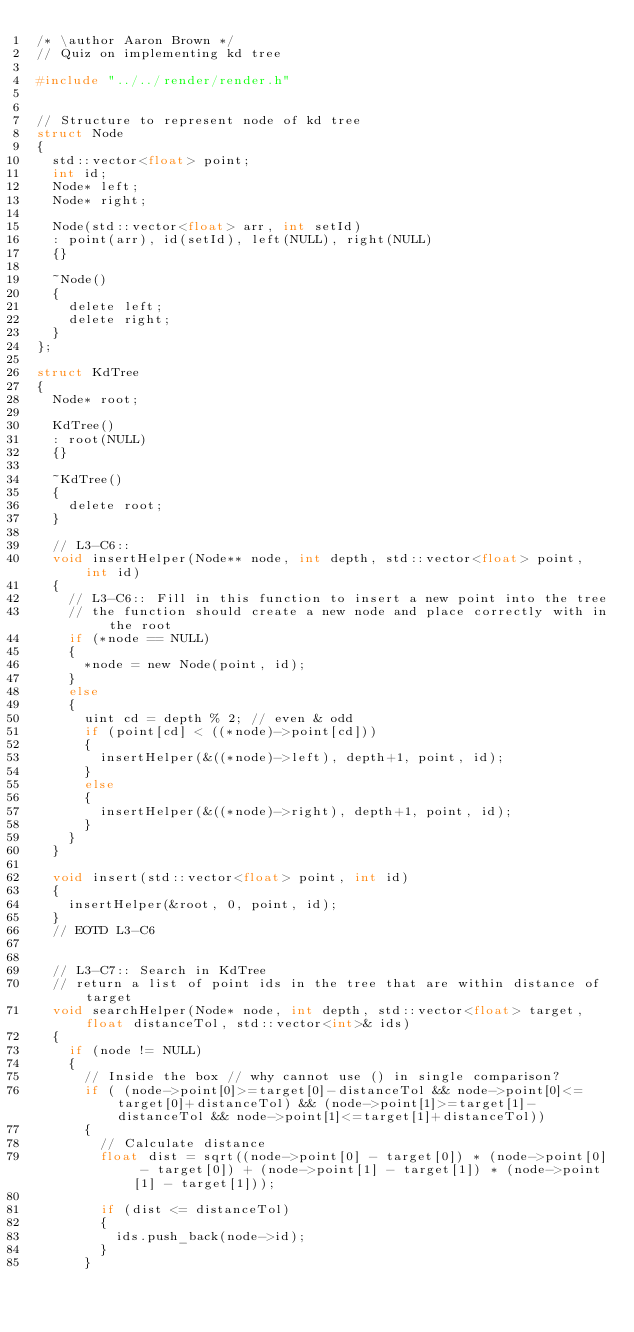Convert code to text. <code><loc_0><loc_0><loc_500><loc_500><_C_>/* \author Aaron Brown */
// Quiz on implementing kd tree

#include "../../render/render.h"


// Structure to represent node of kd tree
struct Node
{
	std::vector<float> point;
	int id;
	Node* left;
	Node* right;

	Node(std::vector<float> arr, int setId)
	:	point(arr), id(setId), left(NULL), right(NULL)
	{}

	~Node()
	{
		delete left;
		delete right;
	}
};

struct KdTree
{
	Node* root;

	KdTree()
	: root(NULL)
	{}

	~KdTree()
	{
		delete root;
	}

	// L3-C6::
	void insertHelper(Node** node, int depth, std::vector<float> point, int id)
	{
		// L3-C6:: Fill in this function to insert a new point into the tree
		// the function should create a new node and place correctly with in the root 
		if (*node == NULL)
		{
			*node = new Node(point, id);
		}
		else
		{
			uint cd = depth % 2; // even & odd
			if (point[cd] < ((*node)->point[cd]))
			{
				insertHelper(&((*node)->left), depth+1, point, id);
			}
			else
			{
				insertHelper(&((*node)->right), depth+1, point, id);
			}
		}
	}

	void insert(std::vector<float> point, int id)
	{
		insertHelper(&root, 0, point, id);
	}
	// EOTD L3-C6


	// L3-C7:: Search in KdTree
	// return a list of point ids in the tree that are within distance of target
	void searchHelper(Node* node, int depth, std::vector<float> target, float distanceTol, std::vector<int>& ids)
	{
		if (node != NULL)
		{
			// Inside the box // why cannot use () in single comparison?
			if ( (node->point[0]>=target[0]-distanceTol && node->point[0]<=target[0]+distanceTol) && (node->point[1]>=target[1]-distanceTol && node->point[1]<=target[1]+distanceTol))
			{
				// Calculate distance
				float dist = sqrt((node->point[0] - target[0]) * (node->point[0] - target[0]) + (node->point[1] - target[1]) * (node->point[1] - target[1]));

				if (dist <= distanceTol)
				{
					ids.push_back(node->id);
				}
			}
</code> 